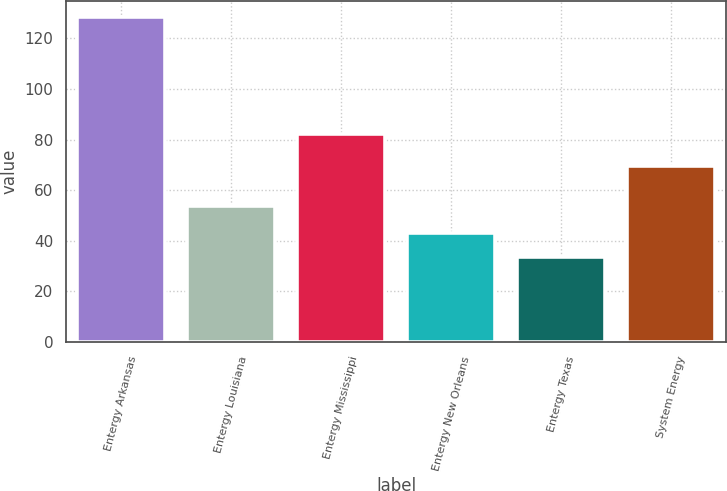Convert chart. <chart><loc_0><loc_0><loc_500><loc_500><bar_chart><fcel>Entergy Arkansas<fcel>Entergy Louisiana<fcel>Entergy Mississippi<fcel>Entergy New Orleans<fcel>Entergy Texas<fcel>System Energy<nl><fcel>128.5<fcel>53.9<fcel>82<fcel>43<fcel>33.5<fcel>69.7<nl></chart> 